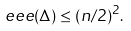<formula> <loc_0><loc_0><loc_500><loc_500>\ e e e ( \Delta ) \leq ( n / 2 ) ^ { 2 } .</formula> 